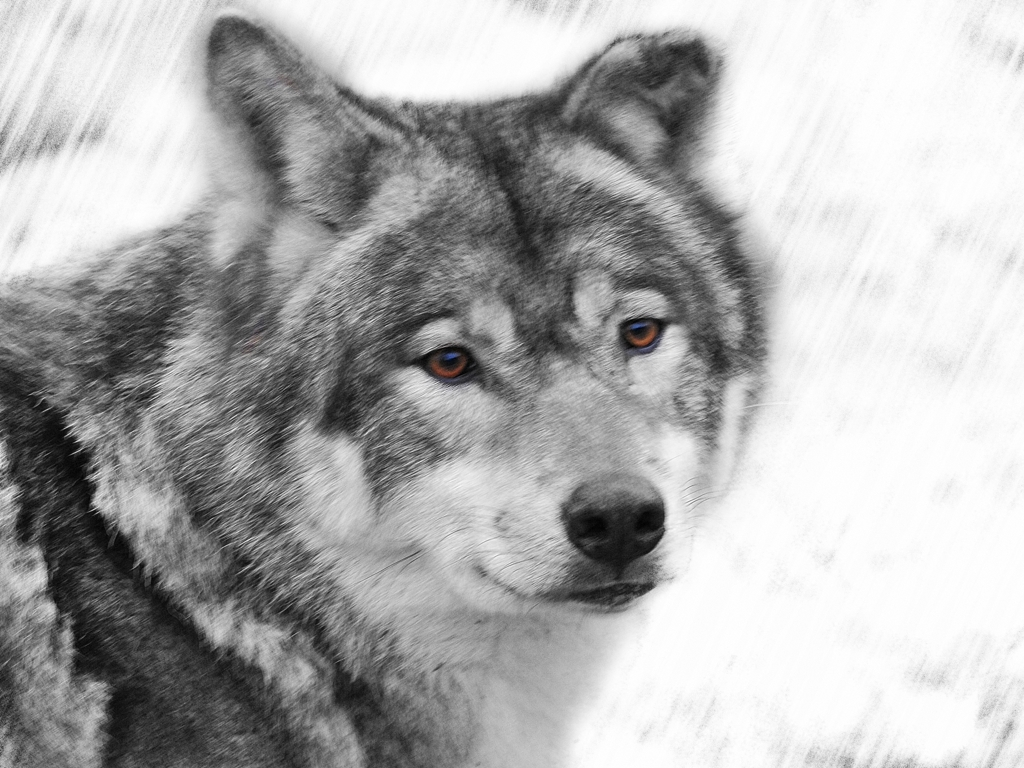What species is depicted in this image? The image shows a wolf, distinguishable by its thick fur, pointed ears, and keen eyes. Can you describe the artistic effect used in this image? Certainly! The artist has used a selective color technique, keeping the eyes of the wolf in color to contrast with the black and white treatment of the rest of the image. This creates a dramatic and focal point on the wolf's gaze. 